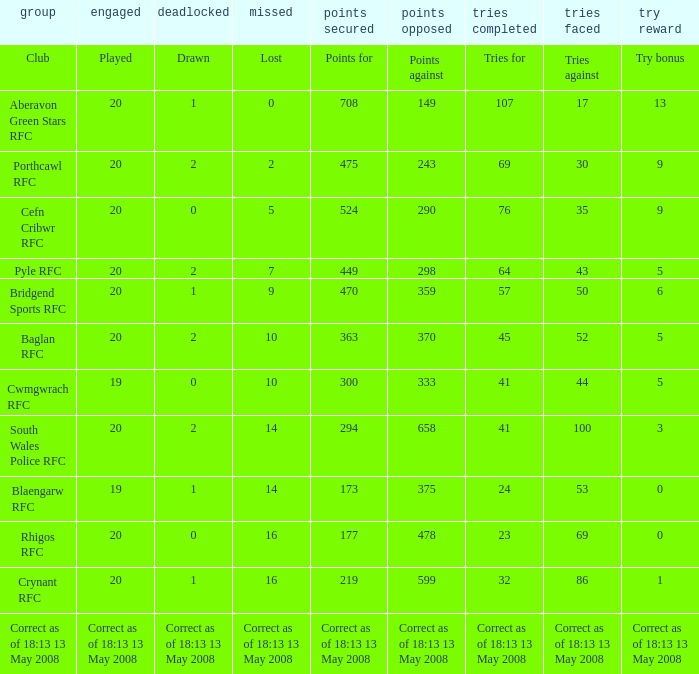What is the lost when the try bonus is 5, and points against is 298? 7.0. 